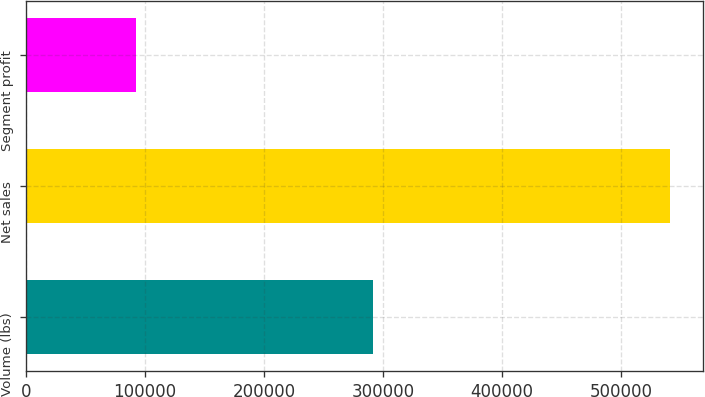Convert chart. <chart><loc_0><loc_0><loc_500><loc_500><bar_chart><fcel>Volume (lbs)<fcel>Net sales<fcel>Segment profit<nl><fcel>291587<fcel>541409<fcel>92299<nl></chart> 